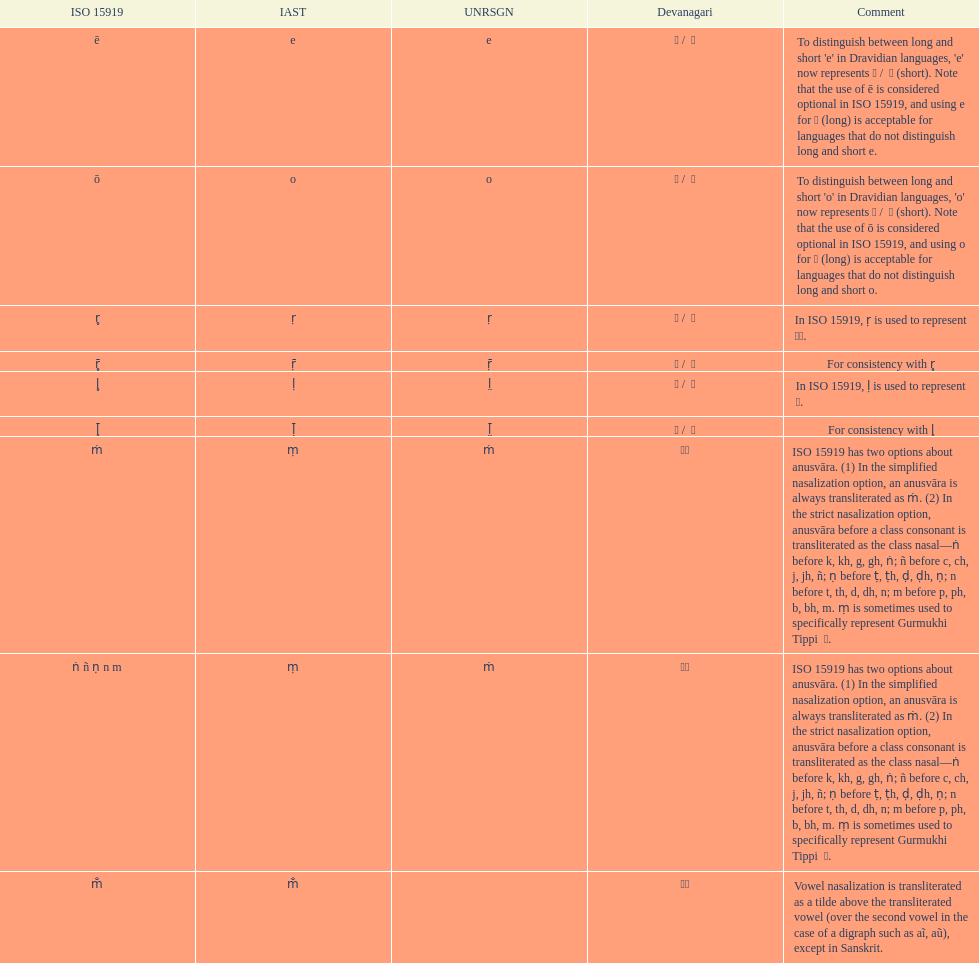What is the total number of translations? 8. Would you mind parsing the complete table? {'header': ['ISO 15919', 'IAST', 'UNRSGN', 'Devanagari', 'Comment'], 'rows': [['ē', 'e', 'e', 'ए / \xa0े', "To distinguish between long and short 'e' in Dravidian languages, 'e' now represents ऎ / \xa0ॆ (short). Note that the use of ē is considered optional in ISO 15919, and using e for ए (long) is acceptable for languages that do not distinguish long and short e."], ['ō', 'o', 'o', 'ओ / \xa0ो', "To distinguish between long and short 'o' in Dravidian languages, 'o' now represents ऒ / \xa0ॊ (short). Note that the use of ō is considered optional in ISO 15919, and using o for ओ (long) is acceptable for languages that do not distinguish long and short o."], ['r̥', 'ṛ', 'ṛ', 'ऋ / \xa0ृ', 'In ISO 15919, ṛ is used to represent ड़.'], ['r̥̄', 'ṝ', 'ṝ', 'ॠ / \xa0ॄ', 'For consistency with r̥'], ['l̥', 'ḷ', 'l̤', 'ऌ / \xa0ॢ', 'In ISO 15919, ḷ is used to represent ळ.'], ['l̥̄', 'ḹ', 'l̤̄', 'ॡ / \xa0ॣ', 'For consistency with l̥'], ['ṁ', 'ṃ', 'ṁ', '◌ं', 'ISO 15919 has two options about anusvāra. (1) In the simplified nasalization option, an anusvāra is always transliterated as ṁ. (2) In the strict nasalization option, anusvāra before a class consonant is transliterated as the class nasal—ṅ before k, kh, g, gh, ṅ; ñ before c, ch, j, jh, ñ; ṇ before ṭ, ṭh, ḍ, ḍh, ṇ; n before t, th, d, dh, n; m before p, ph, b, bh, m. ṃ is sometimes used to specifically represent Gurmukhi Tippi \xa0ੰ.'], ['ṅ ñ ṇ n m', 'ṃ', 'ṁ', '◌ं', 'ISO 15919 has two options about anusvāra. (1) In the simplified nasalization option, an anusvāra is always transliterated as ṁ. (2) In the strict nasalization option, anusvāra before a class consonant is transliterated as the class nasal—ṅ before k, kh, g, gh, ṅ; ñ before c, ch, j, jh, ñ; ṇ before ṭ, ṭh, ḍ, ḍh, ṇ; n before t, th, d, dh, n; m before p, ph, b, bh, m. ṃ is sometimes used to specifically represent Gurmukhi Tippi \xa0ੰ.'], ['m̐', 'm̐', '', '◌ँ', 'Vowel nasalization is transliterated as a tilde above the transliterated vowel (over the second vowel in the case of a digraph such as aĩ, aũ), except in Sanskrit.']]} 